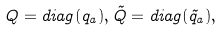<formula> <loc_0><loc_0><loc_500><loc_500>Q = d i a g ( q _ { a } ) , \tilde { Q } = d i a g ( \tilde { q } _ { a } ) ,</formula> 